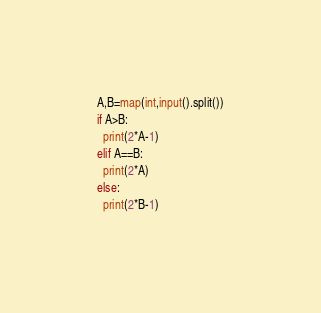Convert code to text. <code><loc_0><loc_0><loc_500><loc_500><_Python_>A,B=map(int,input().split())
if A>B:
  print(2*A-1)
elif A==B:
  print(2*A)
else:
  print(2*B-1)</code> 